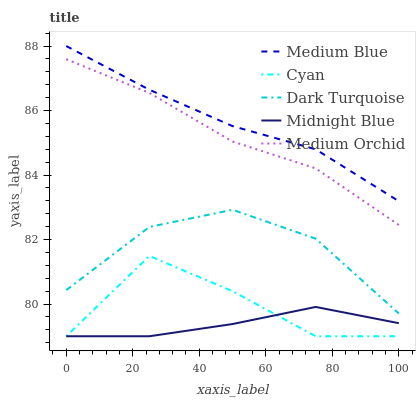Does Midnight Blue have the minimum area under the curve?
Answer yes or no. Yes. Does Medium Blue have the maximum area under the curve?
Answer yes or no. Yes. Does Medium Orchid have the minimum area under the curve?
Answer yes or no. No. Does Medium Orchid have the maximum area under the curve?
Answer yes or no. No. Is Medium Blue the smoothest?
Answer yes or no. Yes. Is Cyan the roughest?
Answer yes or no. Yes. Is Medium Orchid the smoothest?
Answer yes or no. No. Is Medium Orchid the roughest?
Answer yes or no. No. Does Cyan have the lowest value?
Answer yes or no. Yes. Does Medium Orchid have the lowest value?
Answer yes or no. No. Does Medium Blue have the highest value?
Answer yes or no. Yes. Does Medium Orchid have the highest value?
Answer yes or no. No. Is Dark Turquoise less than Medium Blue?
Answer yes or no. Yes. Is Medium Blue greater than Dark Turquoise?
Answer yes or no. Yes. Does Cyan intersect Midnight Blue?
Answer yes or no. Yes. Is Cyan less than Midnight Blue?
Answer yes or no. No. Is Cyan greater than Midnight Blue?
Answer yes or no. No. Does Dark Turquoise intersect Medium Blue?
Answer yes or no. No. 